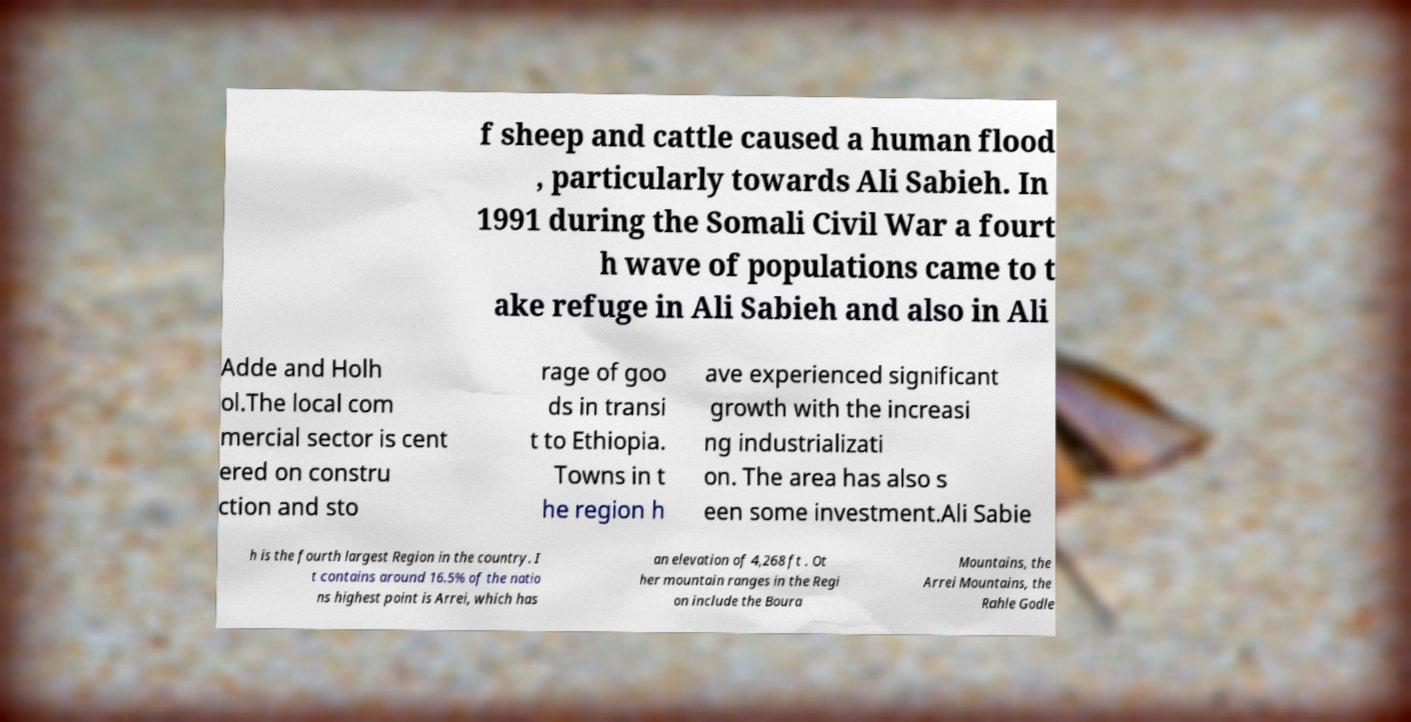Could you extract and type out the text from this image? f sheep and cattle caused a human flood , particularly towards Ali Sabieh. In 1991 during the Somali Civil War a fourt h wave of populations came to t ake refuge in Ali Sabieh and also in Ali Adde and Holh ol.The local com mercial sector is cent ered on constru ction and sto rage of goo ds in transi t to Ethiopia. Towns in t he region h ave experienced significant growth with the increasi ng industrializati on. The area has also s een some investment.Ali Sabie h is the fourth largest Region in the country. I t contains around 16.5% of the natio ns highest point is Arrei, which has an elevation of 4,268 ft . Ot her mountain ranges in the Regi on include the Boura Mountains, the Arrei Mountains, the Rahle Godle 